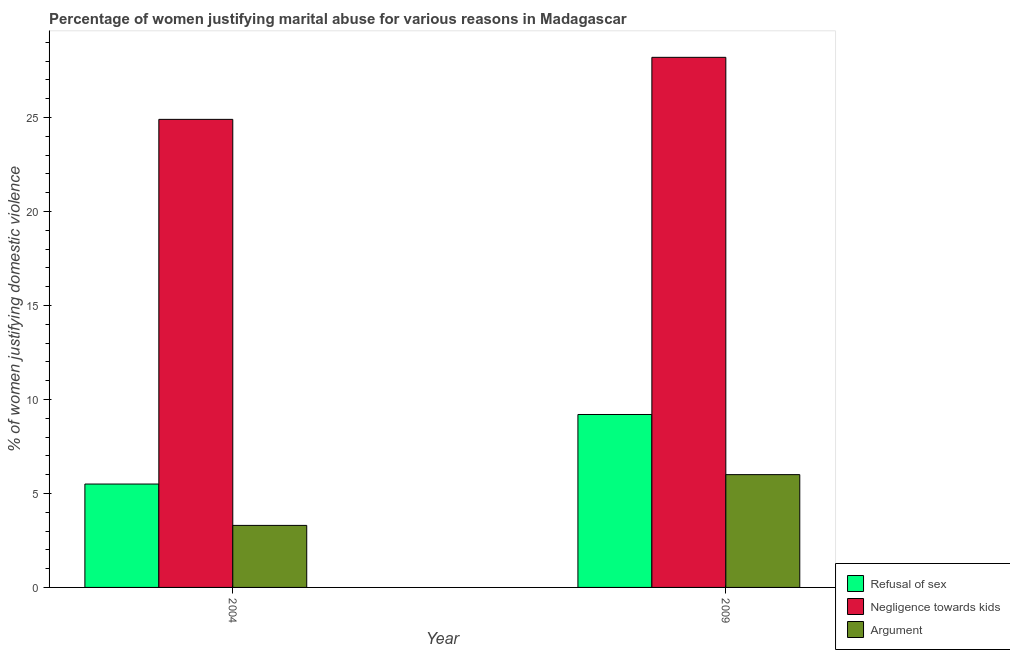How many different coloured bars are there?
Give a very brief answer. 3. Are the number of bars on each tick of the X-axis equal?
Give a very brief answer. Yes. How many bars are there on the 1st tick from the right?
Make the answer very short. 3. In how many cases, is the number of bars for a given year not equal to the number of legend labels?
Keep it short and to the point. 0. What is the percentage of women justifying domestic violence due to negligence towards kids in 2004?
Your answer should be very brief. 24.9. Across all years, what is the minimum percentage of women justifying domestic violence due to negligence towards kids?
Offer a very short reply. 24.9. In which year was the percentage of women justifying domestic violence due to negligence towards kids maximum?
Ensure brevity in your answer.  2009. What is the difference between the percentage of women justifying domestic violence due to refusal of sex in 2004 and that in 2009?
Provide a short and direct response. -3.7. What is the average percentage of women justifying domestic violence due to negligence towards kids per year?
Make the answer very short. 26.55. In how many years, is the percentage of women justifying domestic violence due to arguments greater than 11 %?
Keep it short and to the point. 0. What is the ratio of the percentage of women justifying domestic violence due to arguments in 2004 to that in 2009?
Your response must be concise. 0.55. What does the 2nd bar from the left in 2004 represents?
Make the answer very short. Negligence towards kids. What does the 2nd bar from the right in 2009 represents?
Your answer should be very brief. Negligence towards kids. Is it the case that in every year, the sum of the percentage of women justifying domestic violence due to refusal of sex and percentage of women justifying domestic violence due to negligence towards kids is greater than the percentage of women justifying domestic violence due to arguments?
Offer a terse response. Yes. How many bars are there?
Your answer should be compact. 6. Are all the bars in the graph horizontal?
Provide a short and direct response. No. How many years are there in the graph?
Ensure brevity in your answer.  2. Are the values on the major ticks of Y-axis written in scientific E-notation?
Keep it short and to the point. No. Does the graph contain any zero values?
Your response must be concise. No. How are the legend labels stacked?
Give a very brief answer. Vertical. What is the title of the graph?
Offer a terse response. Percentage of women justifying marital abuse for various reasons in Madagascar. Does "Natural Gas" appear as one of the legend labels in the graph?
Offer a very short reply. No. What is the label or title of the Y-axis?
Your answer should be very brief. % of women justifying domestic violence. What is the % of women justifying domestic violence in Refusal of sex in 2004?
Provide a succinct answer. 5.5. What is the % of women justifying domestic violence of Negligence towards kids in 2004?
Your answer should be compact. 24.9. What is the % of women justifying domestic violence of Negligence towards kids in 2009?
Give a very brief answer. 28.2. Across all years, what is the maximum % of women justifying domestic violence of Refusal of sex?
Give a very brief answer. 9.2. Across all years, what is the maximum % of women justifying domestic violence of Negligence towards kids?
Give a very brief answer. 28.2. Across all years, what is the maximum % of women justifying domestic violence of Argument?
Provide a succinct answer. 6. Across all years, what is the minimum % of women justifying domestic violence of Negligence towards kids?
Ensure brevity in your answer.  24.9. What is the total % of women justifying domestic violence in Negligence towards kids in the graph?
Provide a succinct answer. 53.1. What is the total % of women justifying domestic violence of Argument in the graph?
Your answer should be compact. 9.3. What is the difference between the % of women justifying domestic violence of Argument in 2004 and that in 2009?
Offer a very short reply. -2.7. What is the difference between the % of women justifying domestic violence in Refusal of sex in 2004 and the % of women justifying domestic violence in Negligence towards kids in 2009?
Offer a terse response. -22.7. What is the difference between the % of women justifying domestic violence of Refusal of sex in 2004 and the % of women justifying domestic violence of Argument in 2009?
Offer a very short reply. -0.5. What is the difference between the % of women justifying domestic violence in Negligence towards kids in 2004 and the % of women justifying domestic violence in Argument in 2009?
Ensure brevity in your answer.  18.9. What is the average % of women justifying domestic violence of Refusal of sex per year?
Ensure brevity in your answer.  7.35. What is the average % of women justifying domestic violence in Negligence towards kids per year?
Provide a succinct answer. 26.55. What is the average % of women justifying domestic violence of Argument per year?
Your answer should be compact. 4.65. In the year 2004, what is the difference between the % of women justifying domestic violence in Refusal of sex and % of women justifying domestic violence in Negligence towards kids?
Provide a succinct answer. -19.4. In the year 2004, what is the difference between the % of women justifying domestic violence in Refusal of sex and % of women justifying domestic violence in Argument?
Give a very brief answer. 2.2. In the year 2004, what is the difference between the % of women justifying domestic violence in Negligence towards kids and % of women justifying domestic violence in Argument?
Your answer should be compact. 21.6. In the year 2009, what is the difference between the % of women justifying domestic violence of Refusal of sex and % of women justifying domestic violence of Negligence towards kids?
Ensure brevity in your answer.  -19. What is the ratio of the % of women justifying domestic violence of Refusal of sex in 2004 to that in 2009?
Make the answer very short. 0.6. What is the ratio of the % of women justifying domestic violence of Negligence towards kids in 2004 to that in 2009?
Ensure brevity in your answer.  0.88. What is the ratio of the % of women justifying domestic violence of Argument in 2004 to that in 2009?
Your answer should be very brief. 0.55. What is the difference between the highest and the second highest % of women justifying domestic violence of Refusal of sex?
Your answer should be compact. 3.7. What is the difference between the highest and the second highest % of women justifying domestic violence in Argument?
Your answer should be compact. 2.7. What is the difference between the highest and the lowest % of women justifying domestic violence of Refusal of sex?
Offer a terse response. 3.7. What is the difference between the highest and the lowest % of women justifying domestic violence of Argument?
Ensure brevity in your answer.  2.7. 